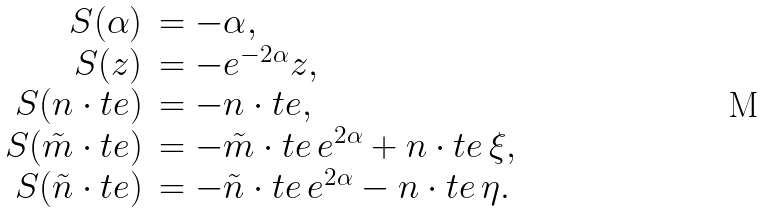<formula> <loc_0><loc_0><loc_500><loc_500>\begin{array} { r l } S ( \alpha ) & = - \alpha , \\ S ( z ) & = - e ^ { - 2 \alpha } z , \\ S ( n \cdot t e ) & = - n \cdot t e , \\ S ( \tilde { m } \cdot t e ) & = - \tilde { m } \cdot t e \, e ^ { 2 \alpha } + n \cdot t e \, \xi , \\ S ( \tilde { n } \cdot t e ) & = - \tilde { n } \cdot t e \, e ^ { 2 \alpha } - n \cdot t e \, \eta . \end{array}</formula> 